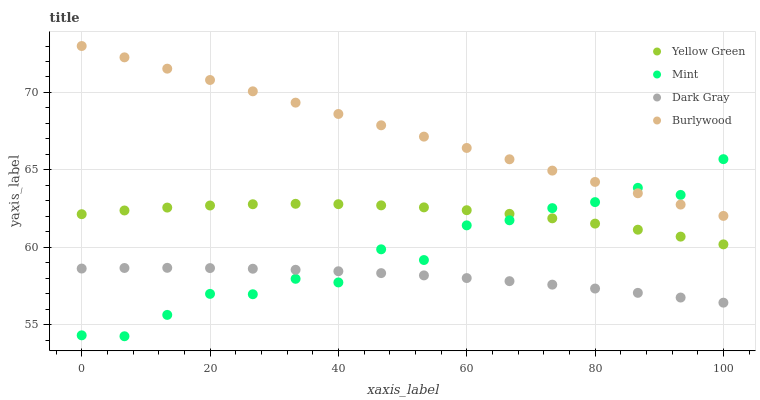Does Dark Gray have the minimum area under the curve?
Answer yes or no. Yes. Does Burlywood have the maximum area under the curve?
Answer yes or no. Yes. Does Mint have the minimum area under the curve?
Answer yes or no. No. Does Mint have the maximum area under the curve?
Answer yes or no. No. Is Burlywood the smoothest?
Answer yes or no. Yes. Is Mint the roughest?
Answer yes or no. Yes. Is Mint the smoothest?
Answer yes or no. No. Is Burlywood the roughest?
Answer yes or no. No. Does Mint have the lowest value?
Answer yes or no. Yes. Does Burlywood have the lowest value?
Answer yes or no. No. Does Burlywood have the highest value?
Answer yes or no. Yes. Does Mint have the highest value?
Answer yes or no. No. Is Dark Gray less than Yellow Green?
Answer yes or no. Yes. Is Burlywood greater than Dark Gray?
Answer yes or no. Yes. Does Mint intersect Dark Gray?
Answer yes or no. Yes. Is Mint less than Dark Gray?
Answer yes or no. No. Is Mint greater than Dark Gray?
Answer yes or no. No. Does Dark Gray intersect Yellow Green?
Answer yes or no. No. 